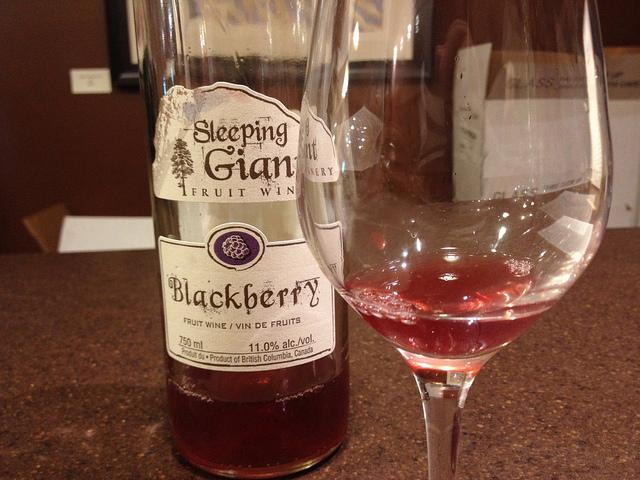What is the percent of alcohol? Please explain your reasoning. 11. On the bottle it states it has 11%. 